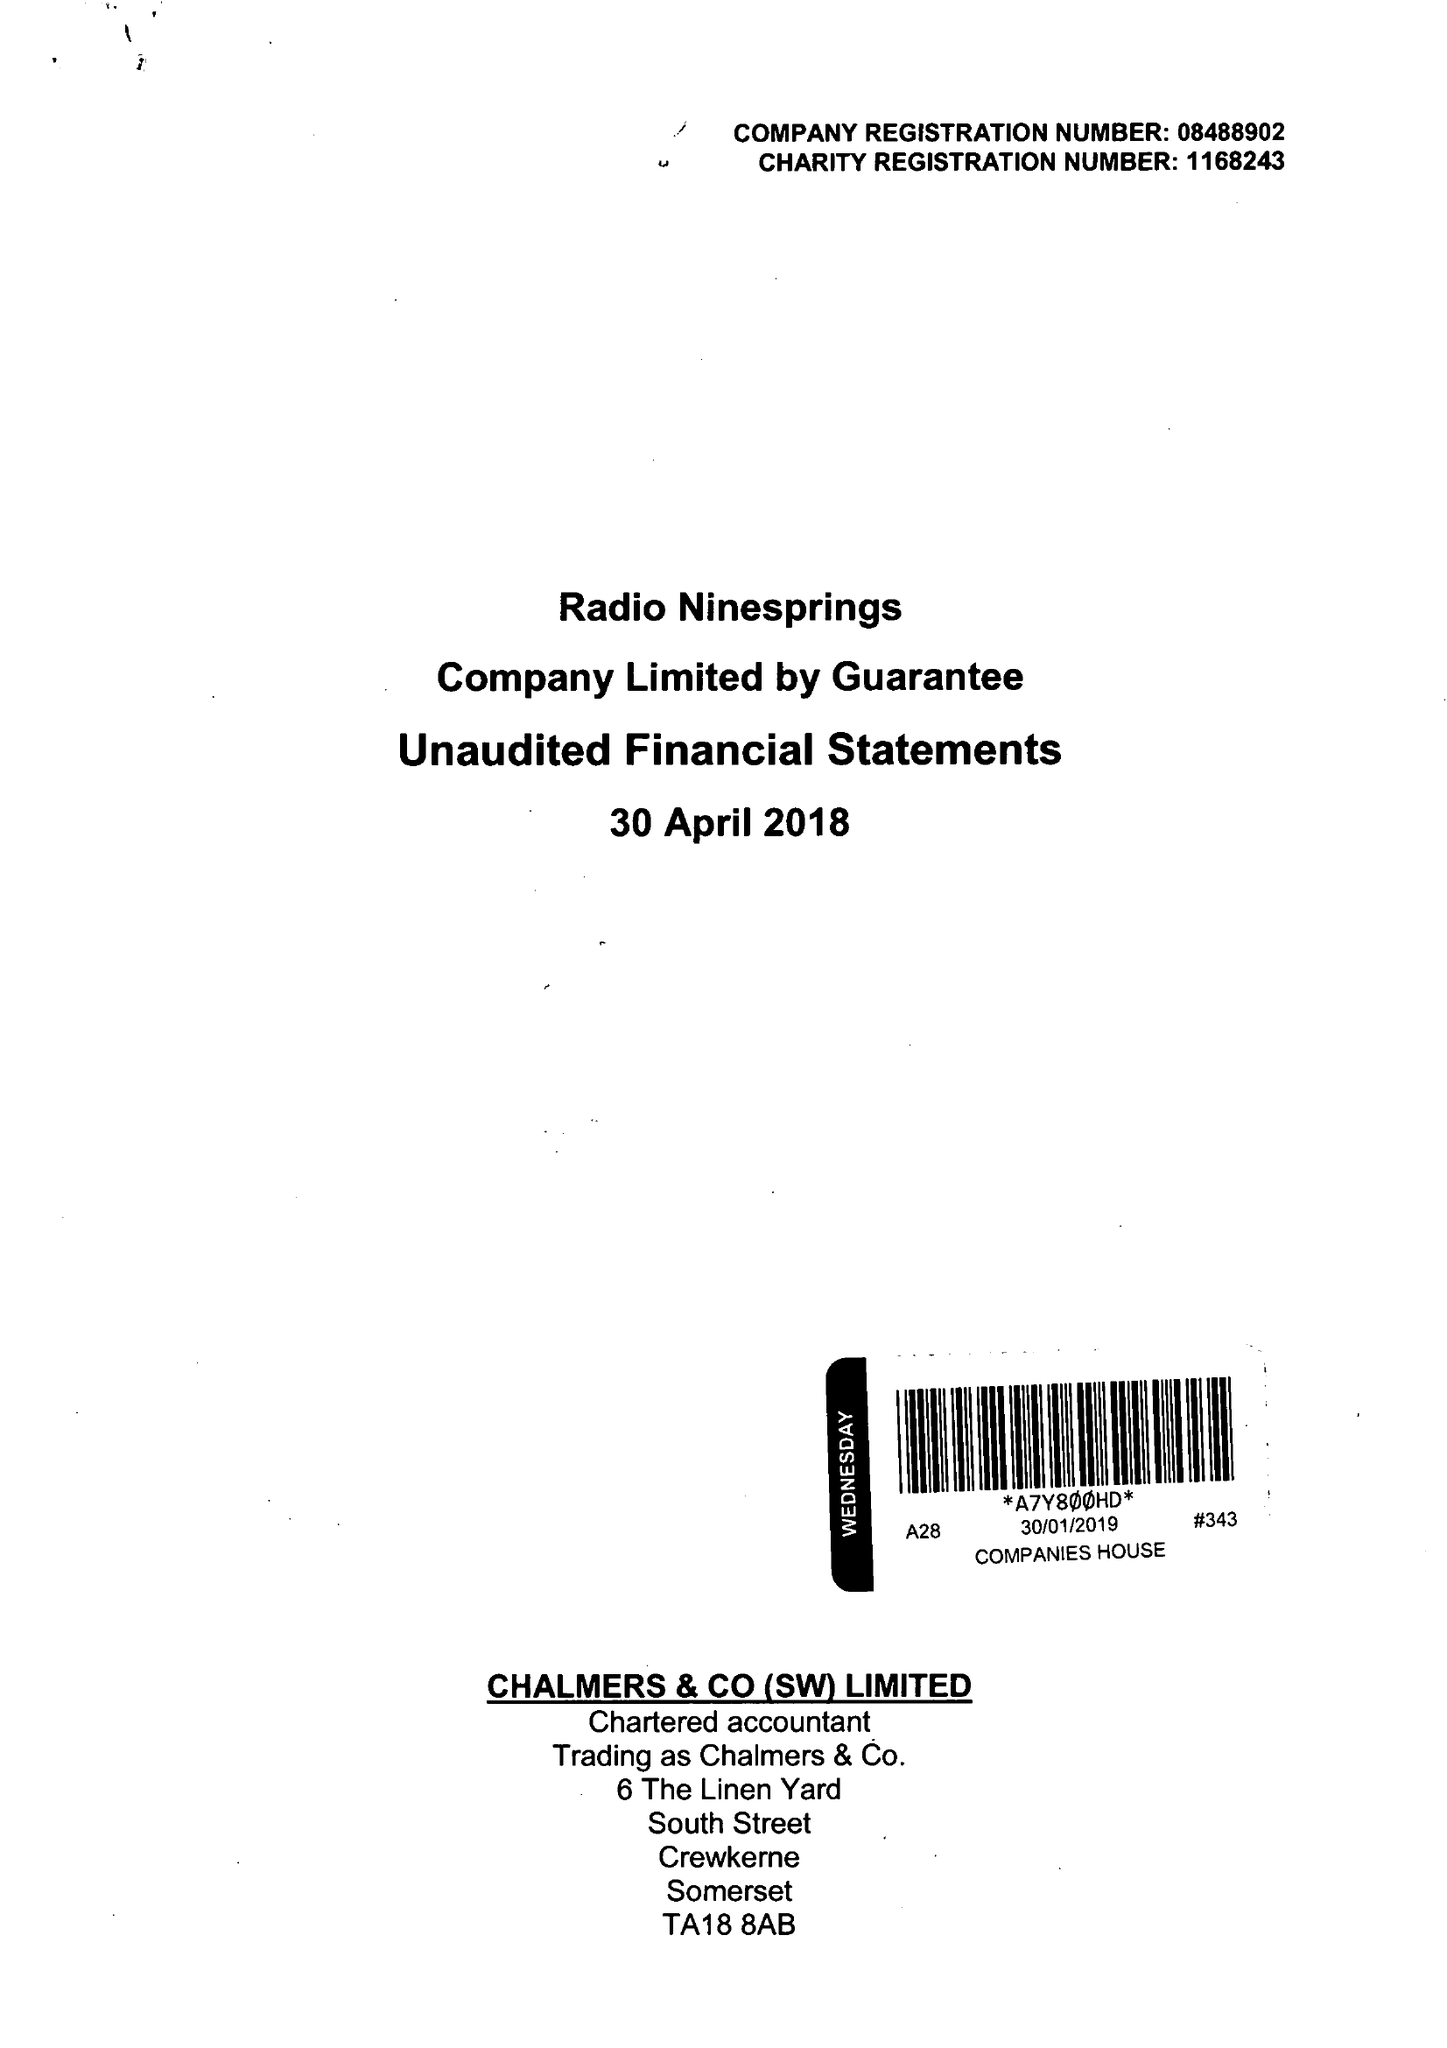What is the value for the report_date?
Answer the question using a single word or phrase. 2018-04-30 